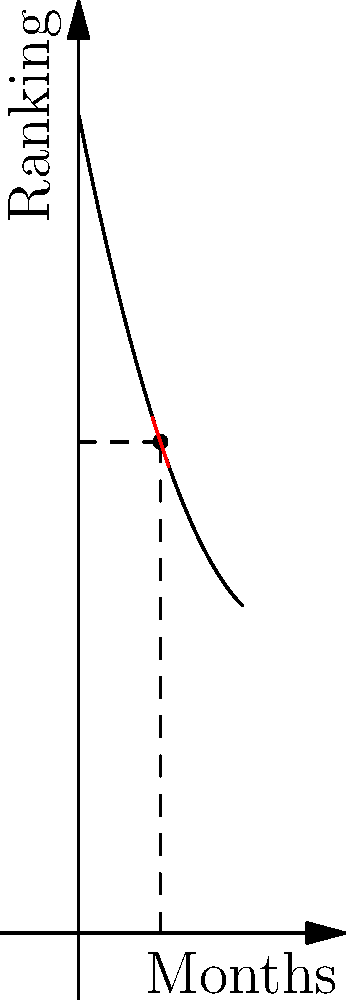As a tennis coach, you're tracking your protégé's ranking over time. The graph shows the player's ranking function $f(x)$, where $x$ represents months and $f(x)$ represents the player's ranking (lower is better). At 10 months, the tangent line to the curve is shown in red. What is the instantaneous rate of change of the player's ranking at this point, and what does it signify about their performance? To solve this problem, we'll follow these steps:

1) The ranking function is given by $f(x) = 100 - 5x + 0.1x^2$.

2) To find the instantaneous rate of change at x = 10 months, we need to calculate the derivative of f(x) at x = 10.

3) The derivative of f(x) is:
   $f'(x) = -5 + 0.2x$

4) At x = 10:
   $f'(10) = -5 + 0.2(10) = -5 + 2 = -3$

5) The negative sign indicates that the ranking is decreasing (which is good in tennis, as lower numbers represent better rankings).

6) The value -3 means that at 10 months, the player's ranking is improving at a rate of 3 positions per month.

This signifies that the player is consistently improving their performance, climbing up the rankings at a steady pace. As a supportive father and coach, this trend would be encouraging, showing that the player's hard work and sacrifices are paying off in terms of improved ranking.
Answer: -3 positions per month, indicating steady improvement 